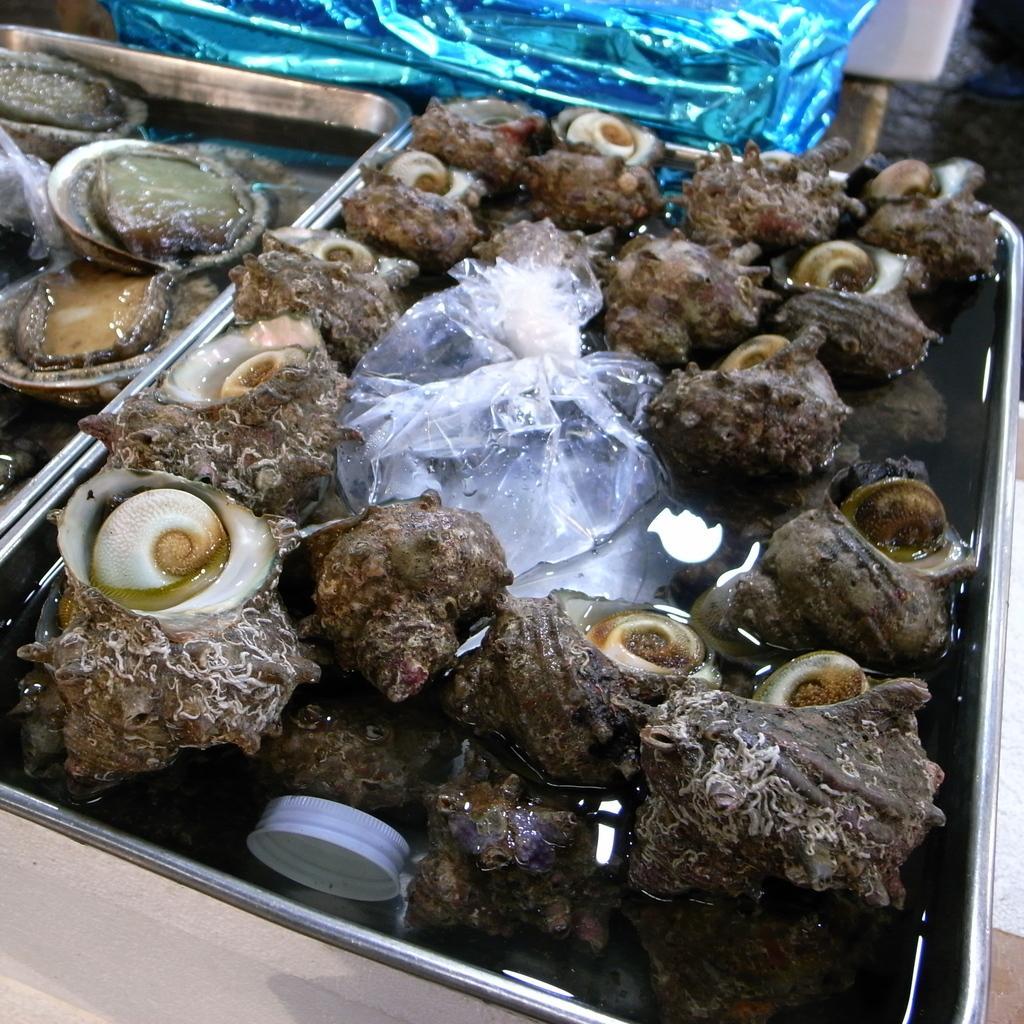Can you describe this image briefly? In this image, we can see sea shells placed in the tray. 